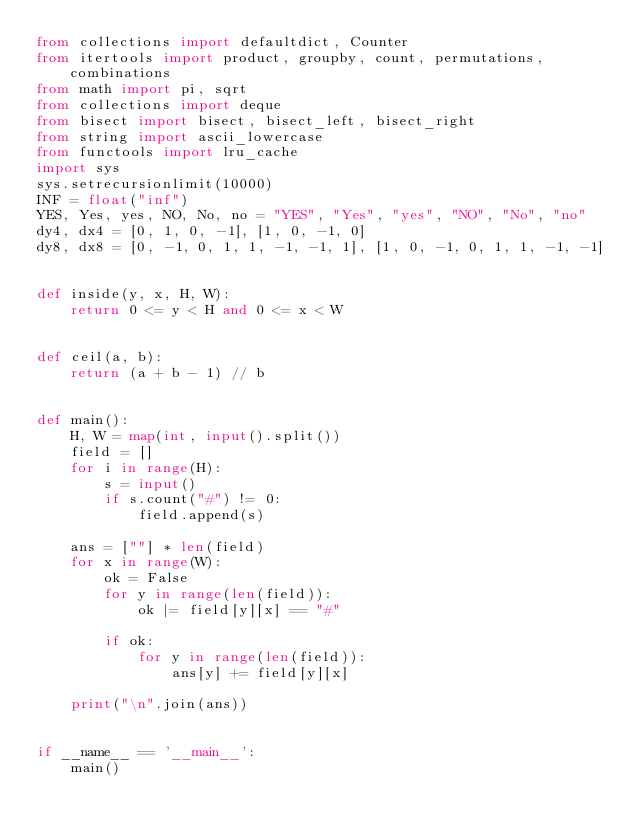Convert code to text. <code><loc_0><loc_0><loc_500><loc_500><_Python_>from collections import defaultdict, Counter
from itertools import product, groupby, count, permutations, combinations
from math import pi, sqrt
from collections import deque
from bisect import bisect, bisect_left, bisect_right
from string import ascii_lowercase
from functools import lru_cache
import sys
sys.setrecursionlimit(10000)
INF = float("inf")
YES, Yes, yes, NO, No, no = "YES", "Yes", "yes", "NO", "No", "no"
dy4, dx4 = [0, 1, 0, -1], [1, 0, -1, 0]
dy8, dx8 = [0, -1, 0, 1, 1, -1, -1, 1], [1, 0, -1, 0, 1, 1, -1, -1]


def inside(y, x, H, W):
    return 0 <= y < H and 0 <= x < W


def ceil(a, b):
    return (a + b - 1) // b


def main():
    H, W = map(int, input().split())
    field = []
    for i in range(H):
        s = input()
        if s.count("#") != 0:
            field.append(s)

    ans = [""] * len(field)
    for x in range(W):
        ok = False
        for y in range(len(field)):
            ok |= field[y][x] == "#"

        if ok:
            for y in range(len(field)):
                ans[y] += field[y][x]

    print("\n".join(ans))


if __name__ == '__main__':
    main()
</code> 